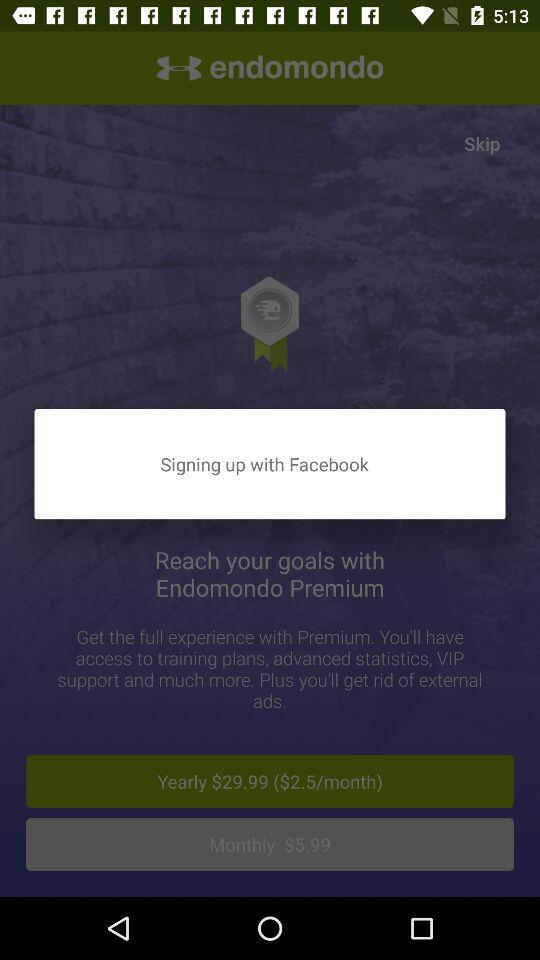What is the yearly cost of the premium? The yearly cost is $29.99. 